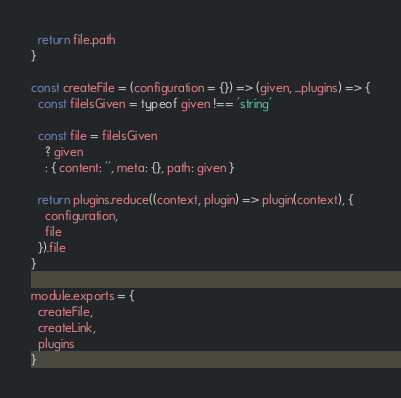Convert code to text. <code><loc_0><loc_0><loc_500><loc_500><_JavaScript_>  return file.path
}

const createFile = (configuration = {}) => (given, ...plugins) => {
  const fileIsGiven = typeof given !== 'string'

  const file = fileIsGiven
    ? given
    : { content: '', meta: {}, path: given }

  return plugins.reduce((context, plugin) => plugin(context), {
    configuration,
    file
  }).file
}

module.exports = {
  createFile,
  createLink,
  plugins
}
</code> 